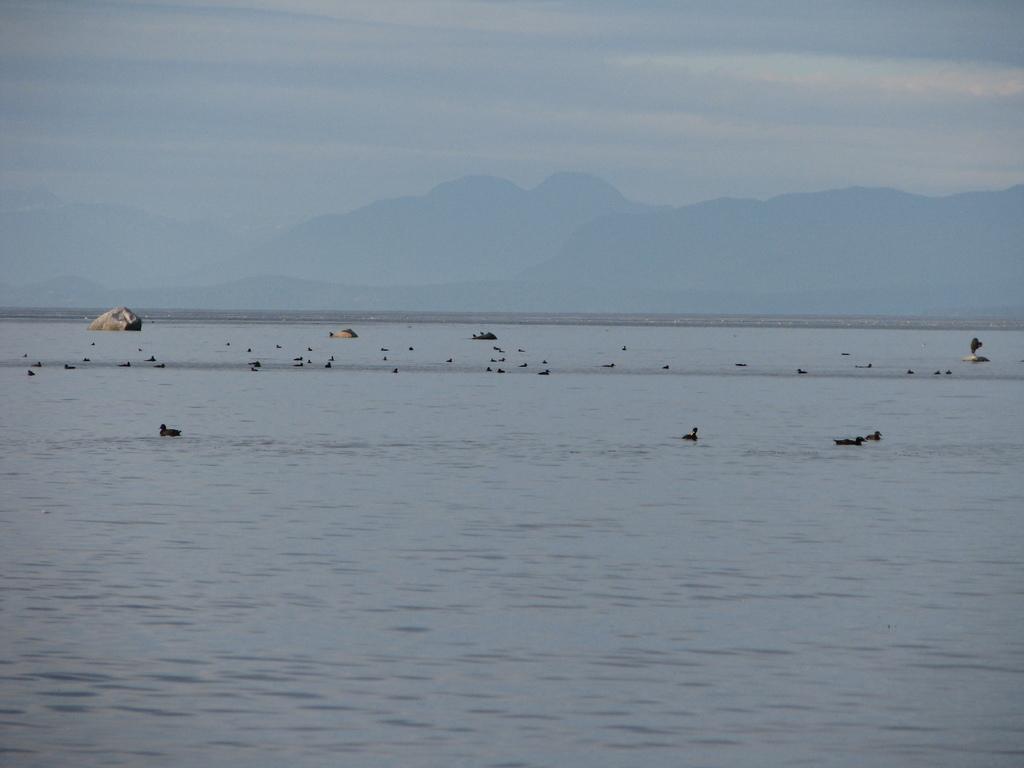Describe this image in one or two sentences. In this image, we can see a sea with few birds. Background we can see few mountains. Top of the image, there is a sky. 